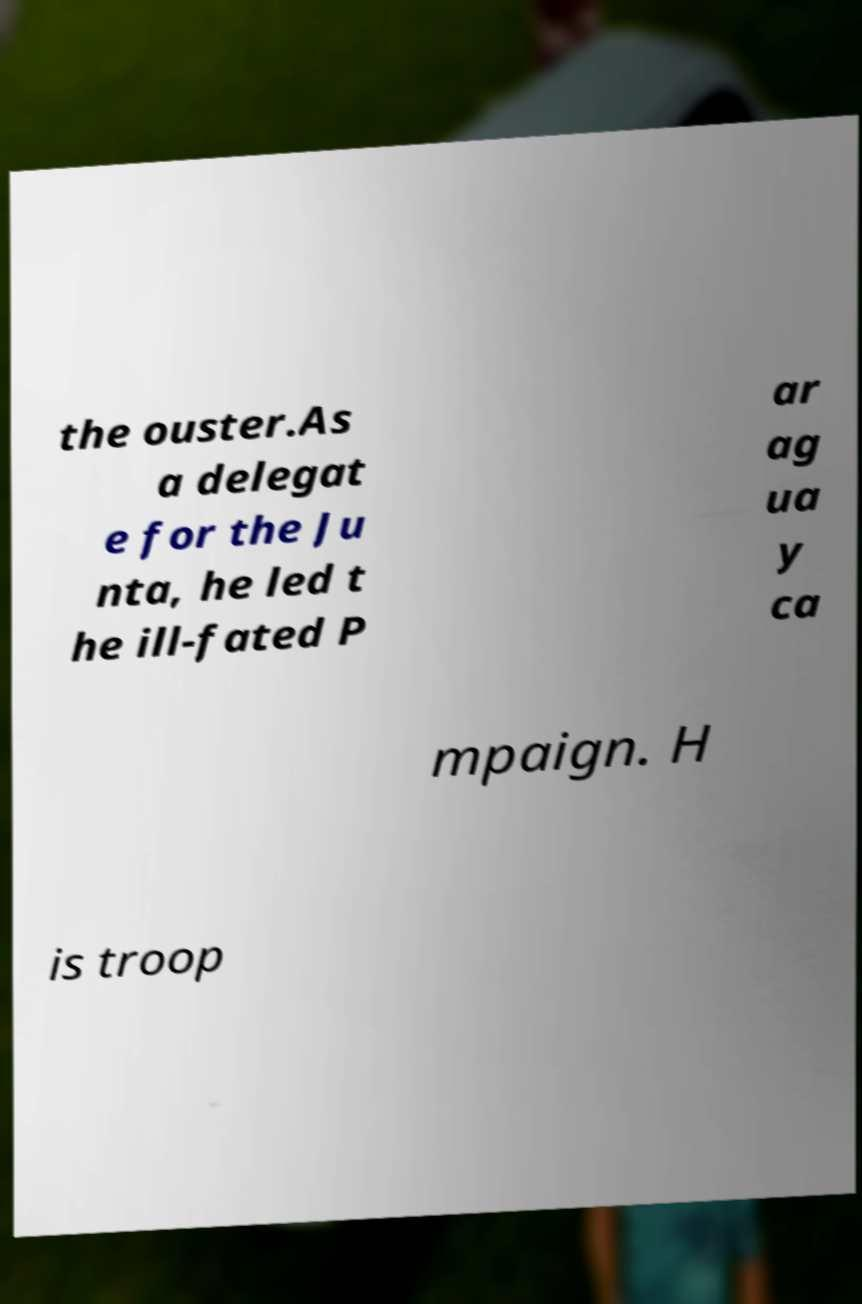Please read and relay the text visible in this image. What does it say? the ouster.As a delegat e for the Ju nta, he led t he ill-fated P ar ag ua y ca mpaign. H is troop 